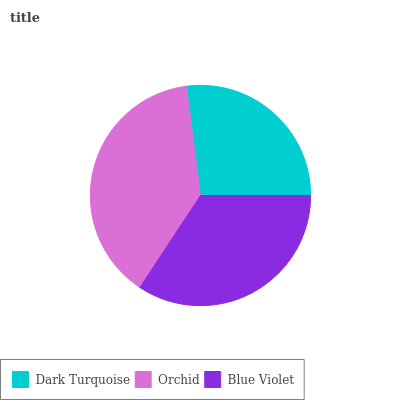Is Dark Turquoise the minimum?
Answer yes or no. Yes. Is Orchid the maximum?
Answer yes or no. Yes. Is Blue Violet the minimum?
Answer yes or no. No. Is Blue Violet the maximum?
Answer yes or no. No. Is Orchid greater than Blue Violet?
Answer yes or no. Yes. Is Blue Violet less than Orchid?
Answer yes or no. Yes. Is Blue Violet greater than Orchid?
Answer yes or no. No. Is Orchid less than Blue Violet?
Answer yes or no. No. Is Blue Violet the high median?
Answer yes or no. Yes. Is Blue Violet the low median?
Answer yes or no. Yes. Is Orchid the high median?
Answer yes or no. No. Is Orchid the low median?
Answer yes or no. No. 